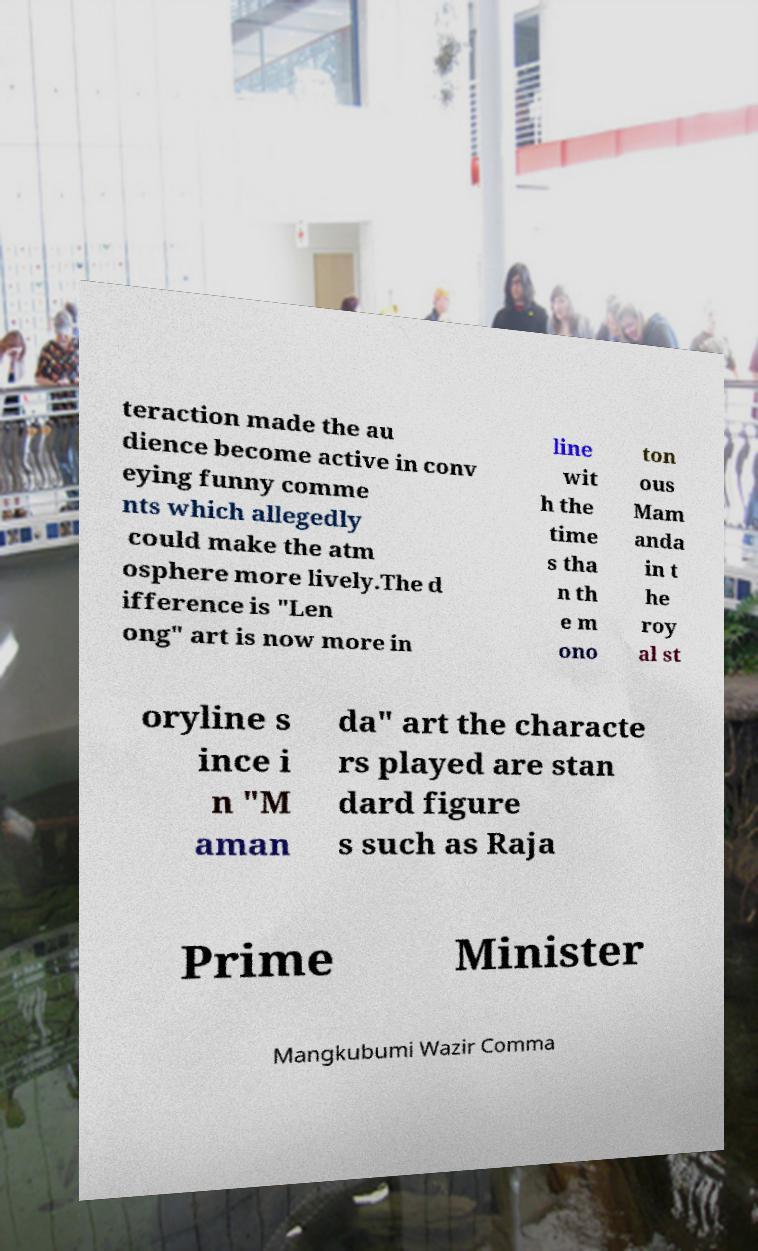Could you extract and type out the text from this image? teraction made the au dience become active in conv eying funny comme nts which allegedly could make the atm osphere more lively.The d ifference is "Len ong" art is now more in line wit h the time s tha n th e m ono ton ous Mam anda in t he roy al st oryline s ince i n "M aman da" art the characte rs played are stan dard figure s such as Raja Prime Minister Mangkubumi Wazir Comma 